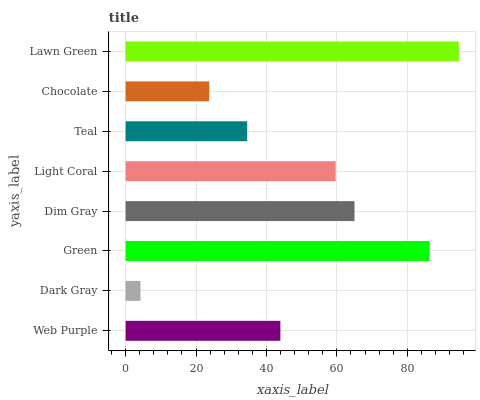Is Dark Gray the minimum?
Answer yes or no. Yes. Is Lawn Green the maximum?
Answer yes or no. Yes. Is Green the minimum?
Answer yes or no. No. Is Green the maximum?
Answer yes or no. No. Is Green greater than Dark Gray?
Answer yes or no. Yes. Is Dark Gray less than Green?
Answer yes or no. Yes. Is Dark Gray greater than Green?
Answer yes or no. No. Is Green less than Dark Gray?
Answer yes or no. No. Is Light Coral the high median?
Answer yes or no. Yes. Is Web Purple the low median?
Answer yes or no. Yes. Is Lawn Green the high median?
Answer yes or no. No. Is Dark Gray the low median?
Answer yes or no. No. 